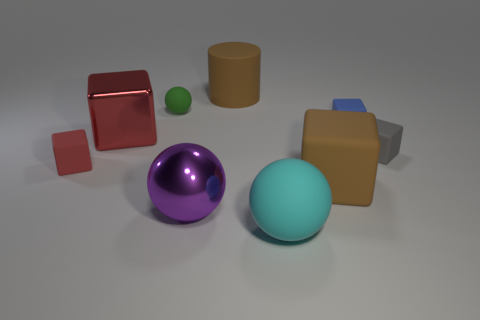Subtract all gray blocks. How many blocks are left? 4 Subtract all blue rubber blocks. How many blocks are left? 4 Subtract all yellow blocks. Subtract all yellow balls. How many blocks are left? 5 Add 1 large purple matte cylinders. How many objects exist? 10 Subtract all blocks. How many objects are left? 4 Add 6 small green matte balls. How many small green matte balls exist? 7 Subtract 0 yellow cylinders. How many objects are left? 9 Subtract all large red shiny objects. Subtract all big cyan rubber cubes. How many objects are left? 8 Add 5 big metal blocks. How many big metal blocks are left? 6 